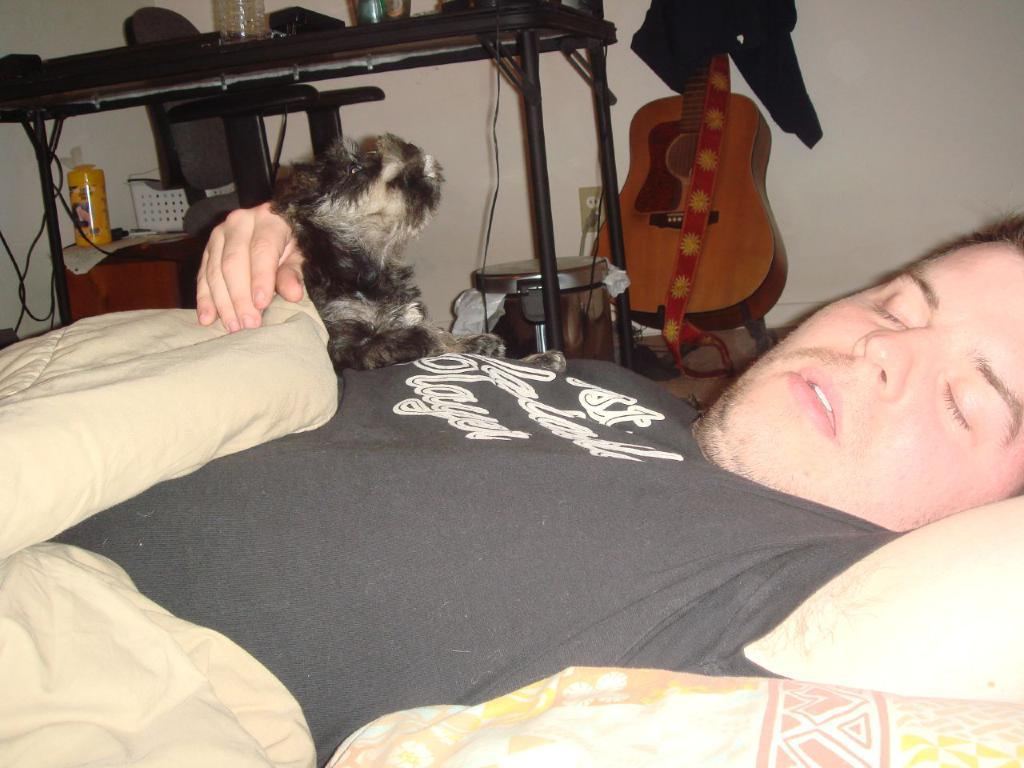What is: What is the man in the image doing? The man is lying on the bed in the image. What is the man holding in his hand? The man is holding a dog in his hand. What musical instruments can be seen in the background of the image? There is a guitar and drums in the background of the image. What object is present on a table in the background of the image? There is a water bottle on a table in the background of the image. How does the man learn to play the guitar in the image? The image does not show the man learning to play the guitar; it only shows the guitar in the background. Can you tell me how many times the man sneezes in the image? There is no indication of the man sneezing in the image. 